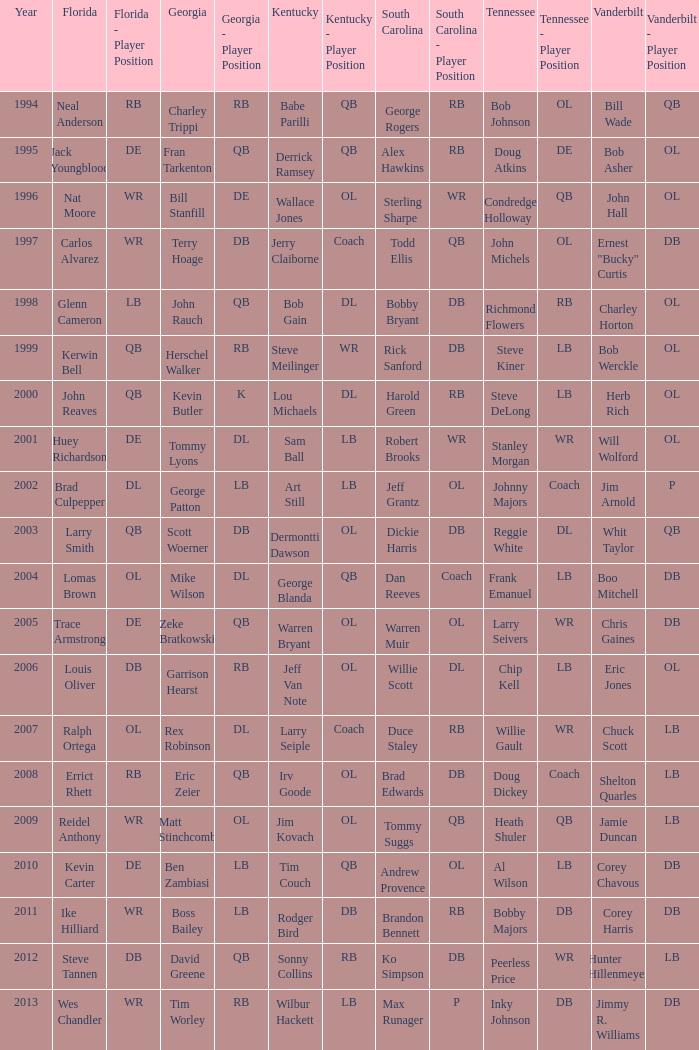What is the Tennessee with a Kentucky of Larry Seiple Willie Gault. 